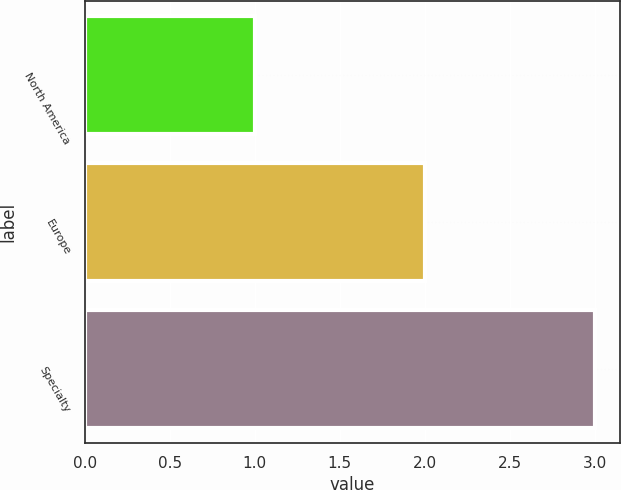Convert chart to OTSL. <chart><loc_0><loc_0><loc_500><loc_500><bar_chart><fcel>North America<fcel>Europe<fcel>Specialty<nl><fcel>1<fcel>2<fcel>3<nl></chart> 